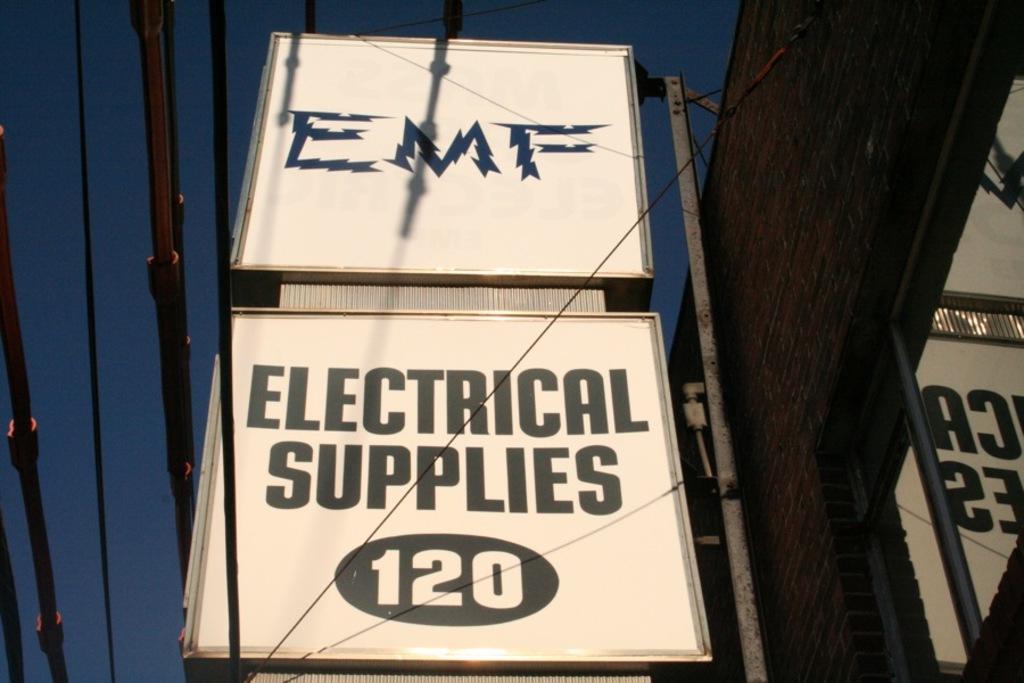What kind of supplies do they sell?
Your response must be concise. Electrical. What is the number on the sign?
Provide a succinct answer. 120. 